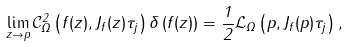Convert formula to latex. <formula><loc_0><loc_0><loc_500><loc_500>\lim _ { z \rightarrow p } \mathcal { C } _ { \Omega } ^ { 2 } \left ( f ( z ) , J _ { f } ( z ) \tau _ { j } \right ) \delta \left ( f ( z ) \right ) = \frac { 1 } { 2 } \mathcal { L } _ { \Omega } \left ( p , J _ { f } ( p ) \tau _ { j } \right ) ,</formula> 